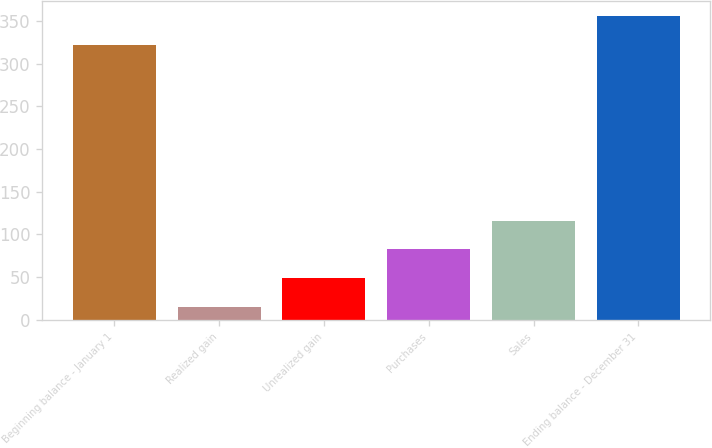Convert chart. <chart><loc_0><loc_0><loc_500><loc_500><bar_chart><fcel>Beginning balance - January 1<fcel>Realized gain<fcel>Unrealized gain<fcel>Purchases<fcel>Sales<fcel>Ending balance - December 31<nl><fcel>322<fcel>15<fcel>48.7<fcel>82.4<fcel>116.1<fcel>355.7<nl></chart> 